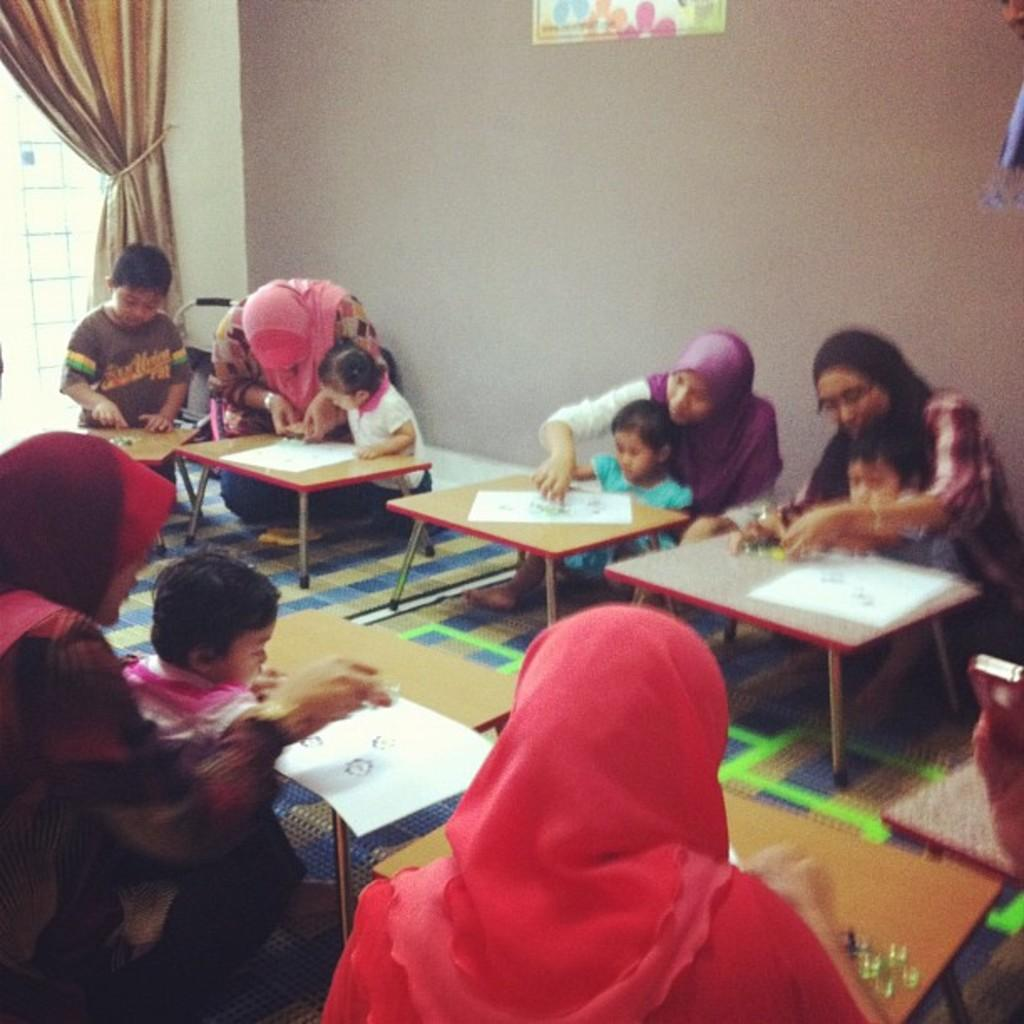How many people are in the image? There is a group of people in the image, but the exact number is not specified. What are the people doing in the image? The people are sitting on the floor in the image. What other object can be seen in the image besides the people? There is a table in the image. What type of balls are being used by the cook in the image? There is no cook or balls present in the image. 